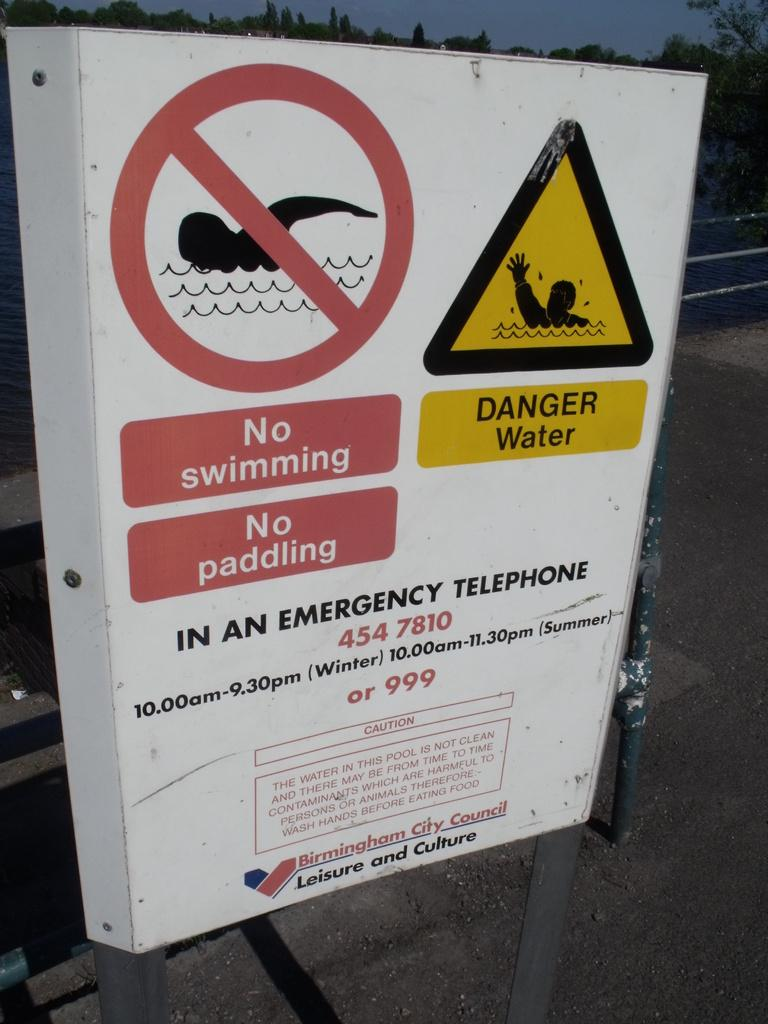<image>
Share a concise interpretation of the image provided. A white warning sign put up by Birmingham City Council to warn against swimming and paddling in water. 